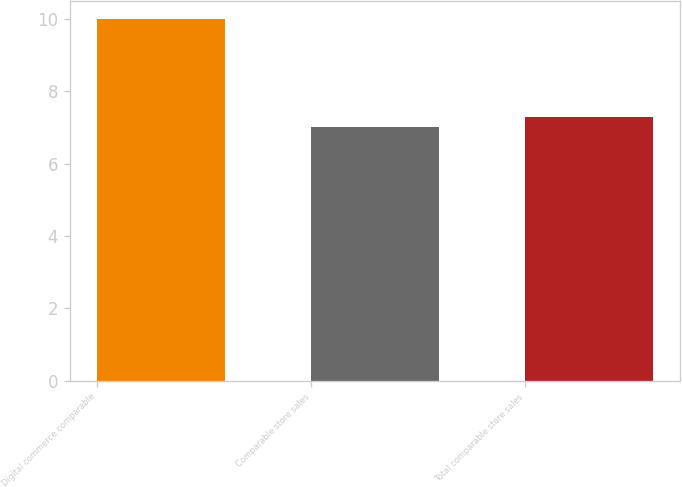Convert chart to OTSL. <chart><loc_0><loc_0><loc_500><loc_500><bar_chart><fcel>Digital commerce comparable<fcel>Comparable store sales<fcel>Total comparable store sales<nl><fcel>10<fcel>7<fcel>7.3<nl></chart> 